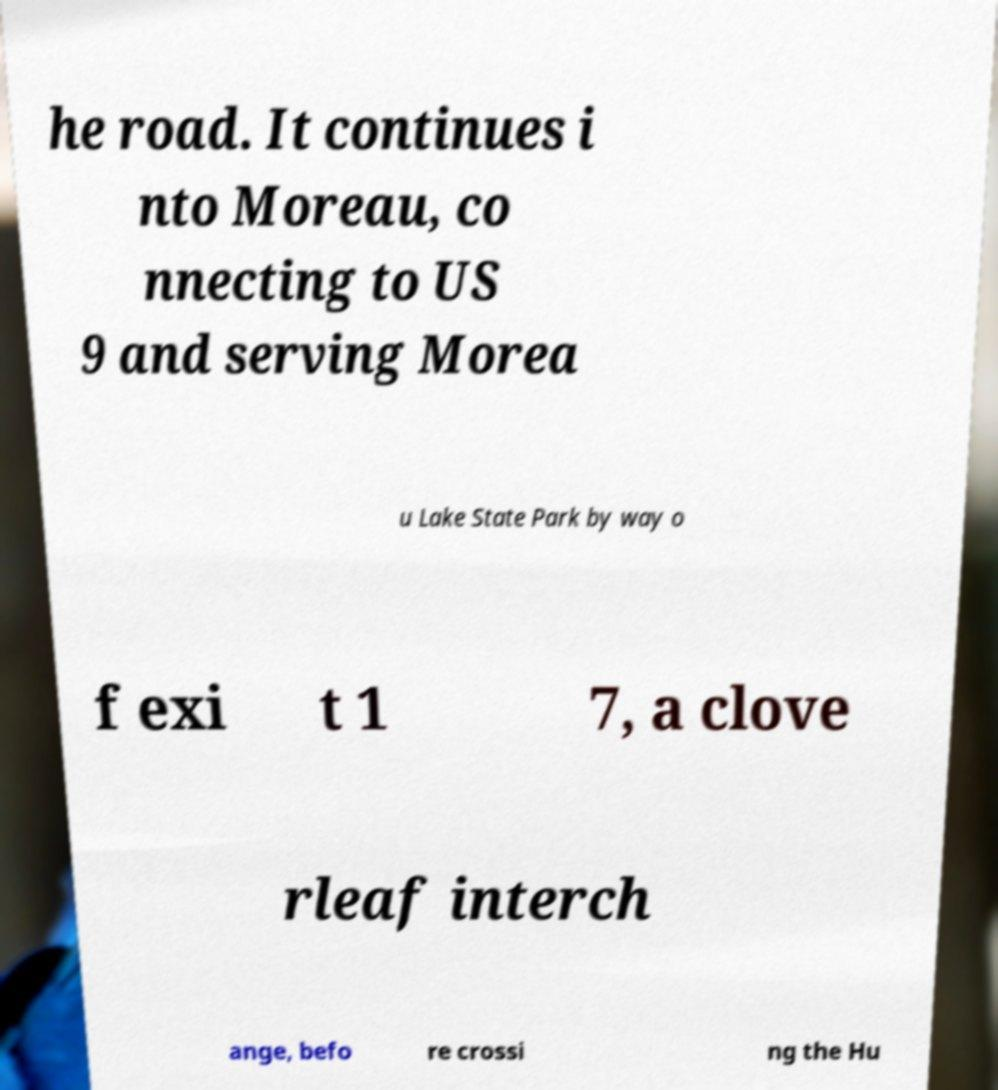Please identify and transcribe the text found in this image. he road. It continues i nto Moreau, co nnecting to US 9 and serving Morea u Lake State Park by way o f exi t 1 7, a clove rleaf interch ange, befo re crossi ng the Hu 